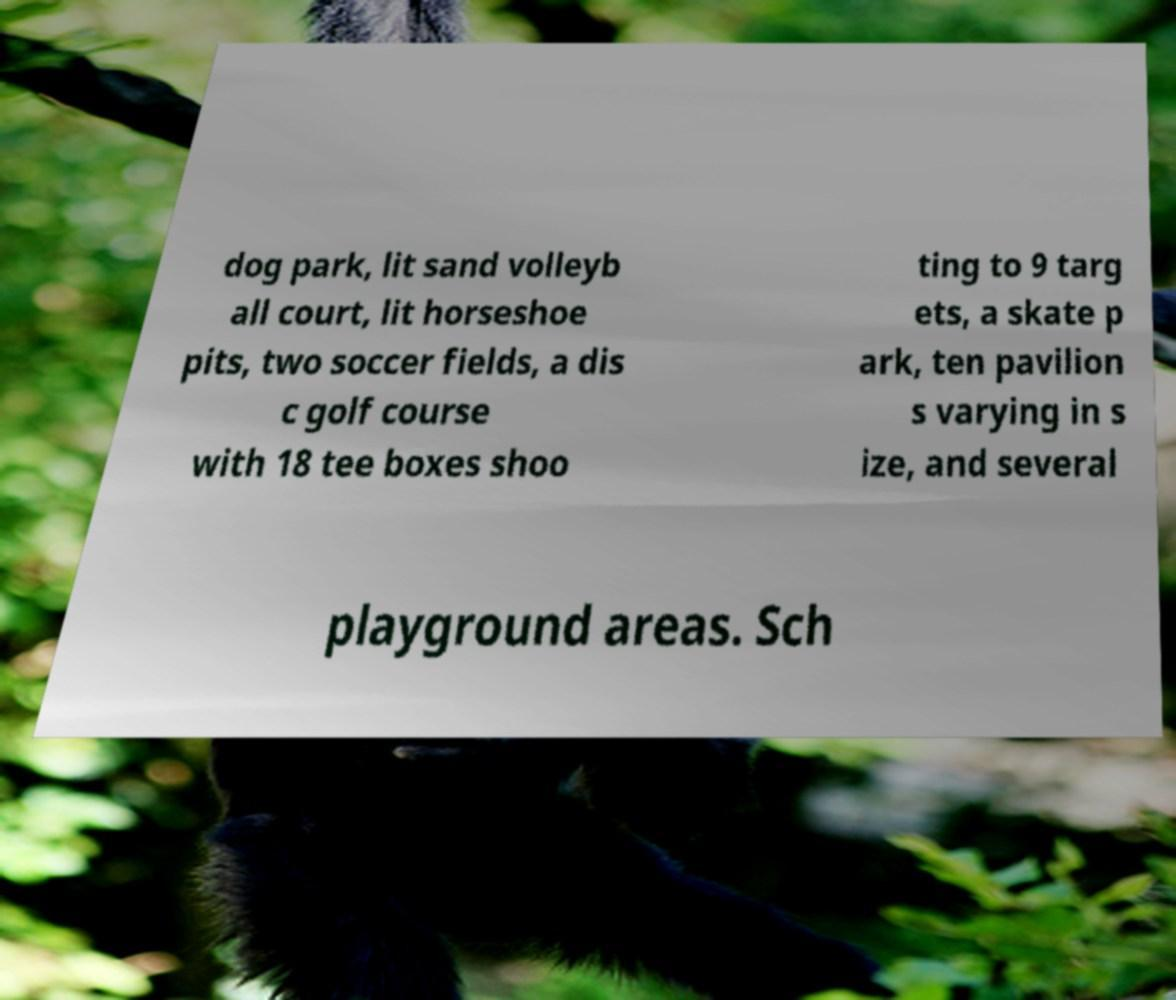What messages or text are displayed in this image? I need them in a readable, typed format. dog park, lit sand volleyb all court, lit horseshoe pits, two soccer fields, a dis c golf course with 18 tee boxes shoo ting to 9 targ ets, a skate p ark, ten pavilion s varying in s ize, and several playground areas. Sch 